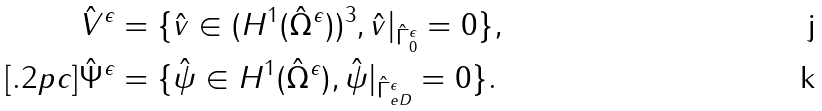<formula> <loc_0><loc_0><loc_500><loc_500>\hat { V } ^ { \epsilon } & = \{ \hat { v } \in ( H ^ { 1 } ( \hat { \Omega } ^ { \epsilon } ) ) ^ { 3 } , \hat { v } | _ { \hat { \Gamma } ^ { \epsilon } _ { 0 } } = 0 \} , \\ [ . 2 p c ] \hat { \Psi } ^ { \epsilon } & = \{ \hat { \psi } \in H ^ { 1 } ( \hat { \Omega } ^ { \epsilon } ) , \hat { \psi } | _ { \hat { \Gamma } _ { e D } ^ { \epsilon } } = 0 \} .</formula> 